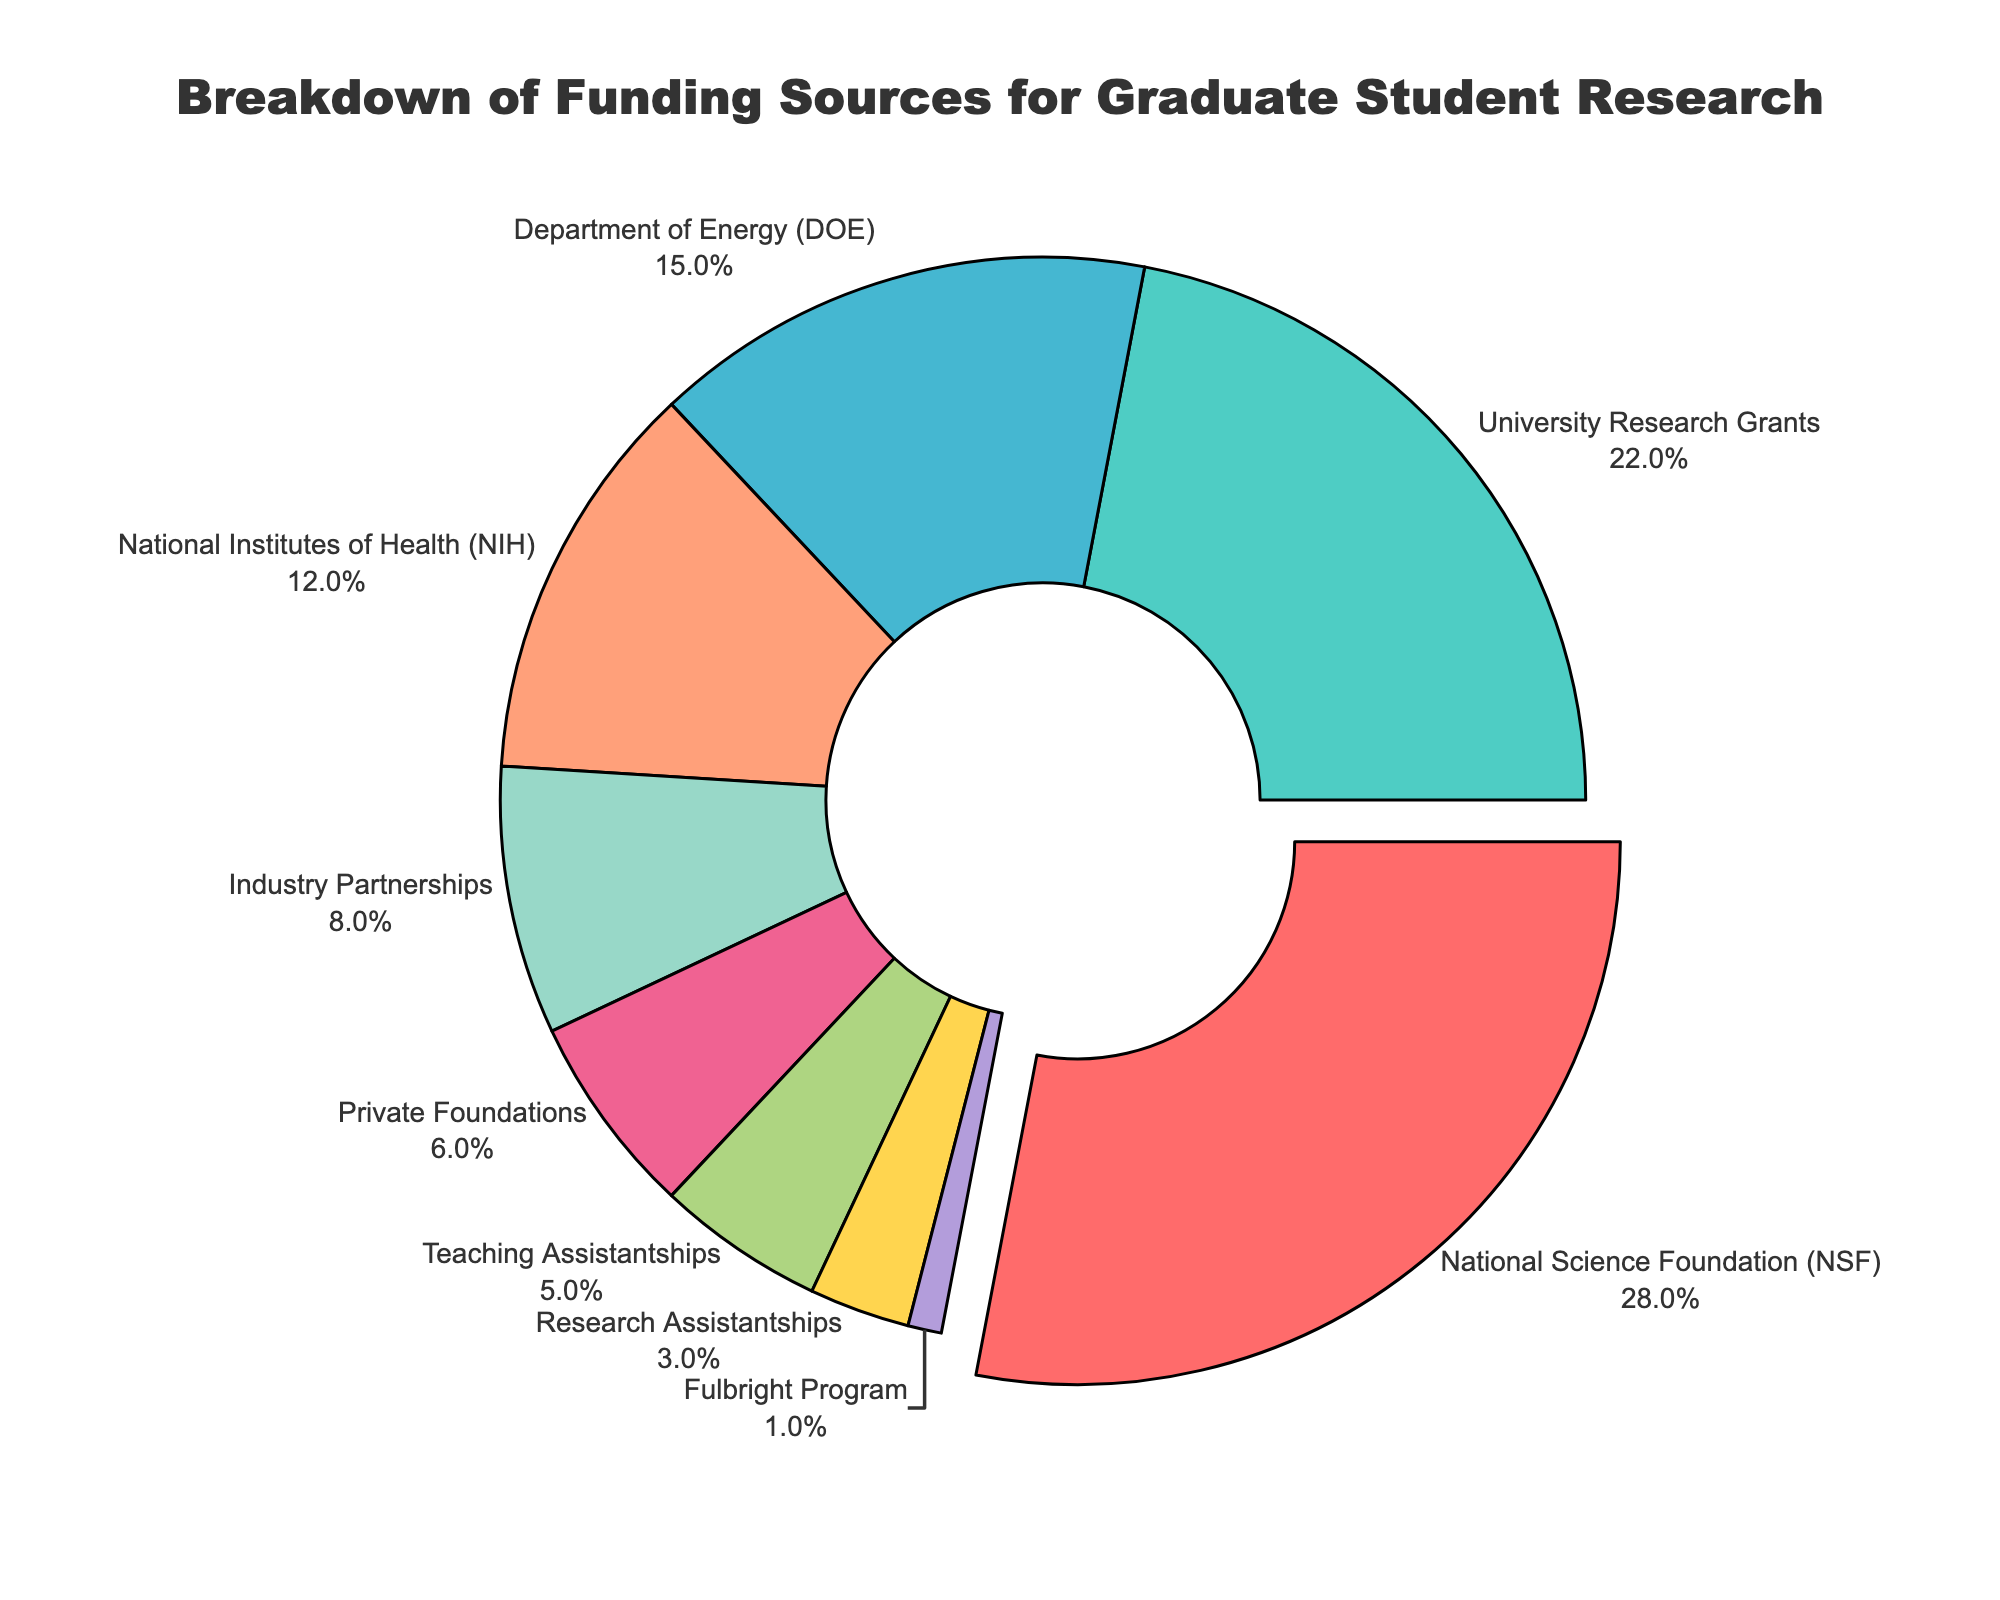What is the largest funding source for graduate student research? The pie chart shows different funding sources with their percentages. The largest segment of the chart is labeled "National Science Foundation (NSF)" with 28%.
Answer: National Science Foundation (NSF) Which funding source provides more funding: Department of Energy (DOE) or National Institutes of Health (NIH)? To determine which source provides more funding, compare their percentages. The DOE provides 15% and the NIH provides 12%. 15% is greater than 12%.
Answer: Department of Energy (DOE) What is the combined percentage of funding from University Research Grants and NSF? Add the percentage of University Research Grants (22%) and the percentage of NSF (28%). 22% + 28% = 50%.
Answer: 50% Which funding source contributes least to the graduate student research funding? The smallest segment of the pie chart is labeled "Fulbright Program" with 1%.
Answer: Fulbright Program How many funding sources contribute less than 10% each? Identify the segments with less than 10%: Industry Partnerships (8%), Private Foundations (6%), Teaching Assistantships (5%), Research Assistantships (3%), and Fulbright Program (1%). Count these segments: 5.
Answer: Five 